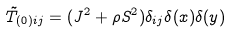Convert formula to latex. <formula><loc_0><loc_0><loc_500><loc_500>\tilde { T } _ { ( 0 ) i j } = ( J ^ { 2 } + \rho S ^ { 2 } ) \delta _ { i j } \delta ( x ) \delta ( y )</formula> 